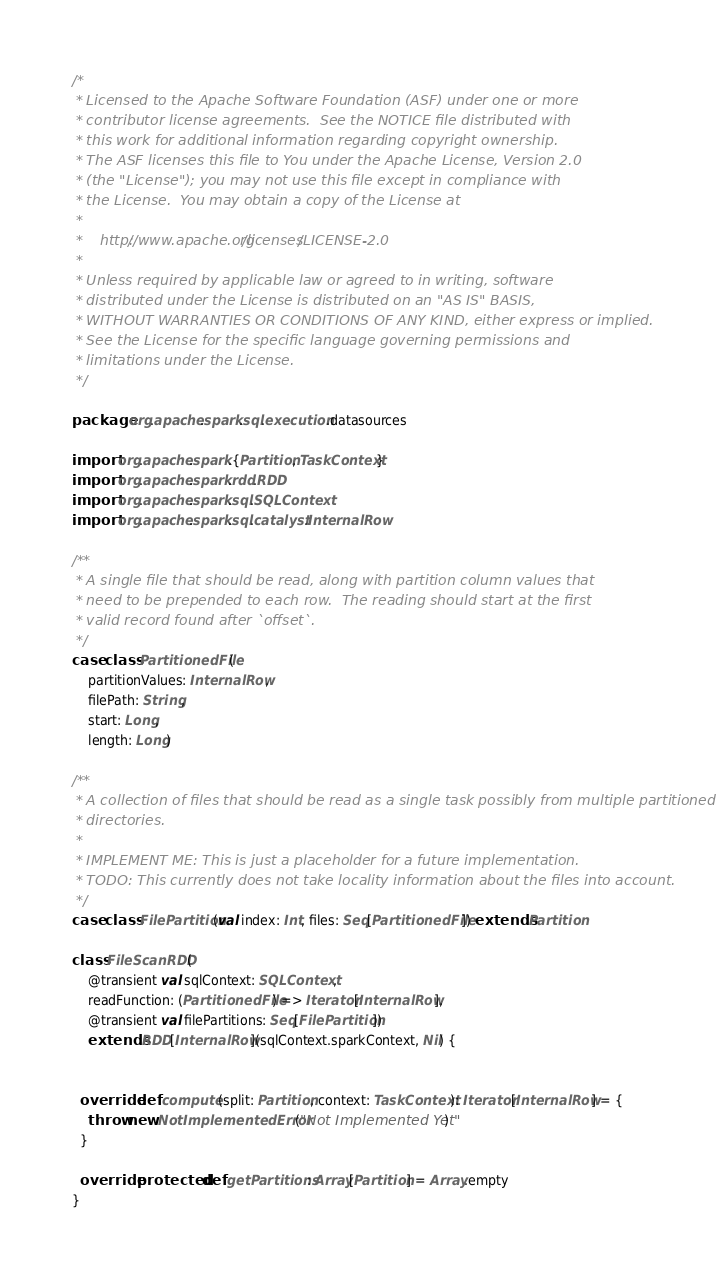Convert code to text. <code><loc_0><loc_0><loc_500><loc_500><_Scala_>/*
 * Licensed to the Apache Software Foundation (ASF) under one or more
 * contributor license agreements.  See the NOTICE file distributed with
 * this work for additional information regarding copyright ownership.
 * The ASF licenses this file to You under the Apache License, Version 2.0
 * (the "License"); you may not use this file except in compliance with
 * the License.  You may obtain a copy of the License at
 *
 *    http://www.apache.org/licenses/LICENSE-2.0
 *
 * Unless required by applicable law or agreed to in writing, software
 * distributed under the License is distributed on an "AS IS" BASIS,
 * WITHOUT WARRANTIES OR CONDITIONS OF ANY KIND, either express or implied.
 * See the License for the specific language governing permissions and
 * limitations under the License.
 */

package org.apache.spark.sql.execution.datasources

import org.apache.spark.{Partition, TaskContext}
import org.apache.spark.rdd.RDD
import org.apache.spark.sql.SQLContext
import org.apache.spark.sql.catalyst.InternalRow

/**
 * A single file that should be read, along with partition column values that
 * need to be prepended to each row.  The reading should start at the first
 * valid record found after `offset`.
 */
case class PartitionedFile(
    partitionValues: InternalRow,
    filePath: String,
    start: Long,
    length: Long)

/**
 * A collection of files that should be read as a single task possibly from multiple partitioned
 * directories.
 *
 * IMPLEMENT ME: This is just a placeholder for a future implementation.
 * TODO: This currently does not take locality information about the files into account.
 */
case class FilePartition(val index: Int, files: Seq[PartitionedFile]) extends Partition

class FileScanRDD(
    @transient val sqlContext: SQLContext,
    readFunction: (PartitionedFile) => Iterator[InternalRow],
    @transient val filePartitions: Seq[FilePartition])
    extends RDD[InternalRow](sqlContext.sparkContext, Nil) {


  override def compute(split: Partition, context: TaskContext): Iterator[InternalRow] = {
    throw new NotImplementedError("Not Implemented Yet")
  }

  override protected def getPartitions: Array[Partition] = Array.empty
}
</code> 